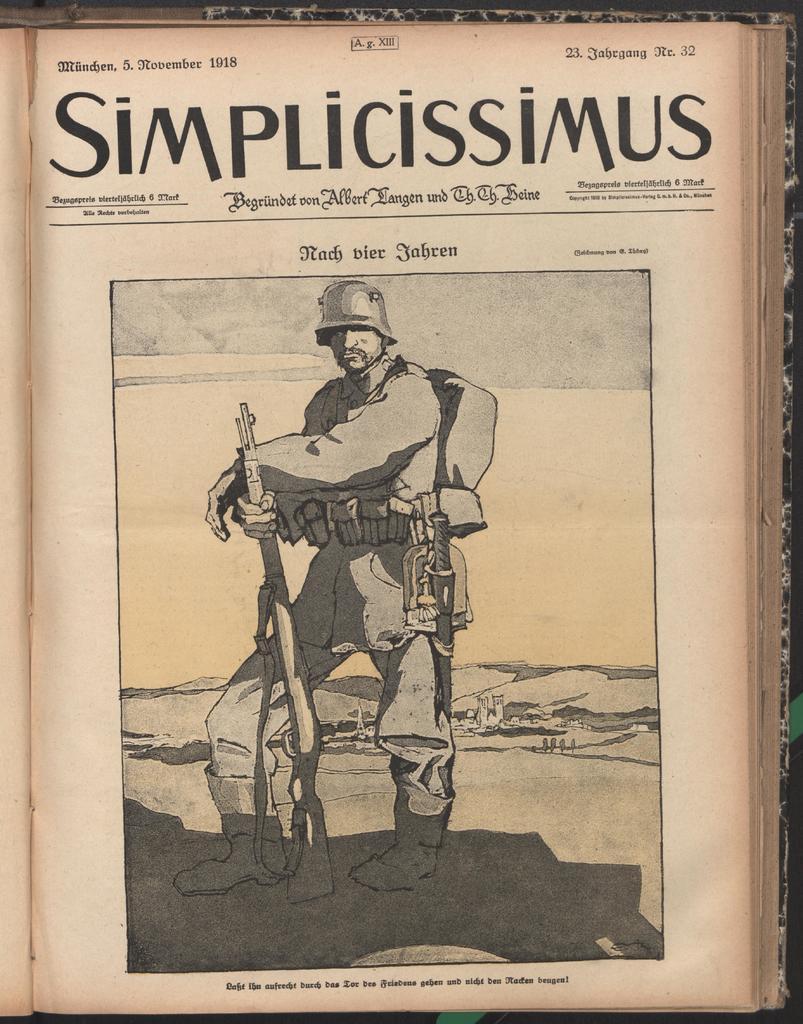In one or two sentences, can you explain what this image depicts? In this image we can see picture of a person and texts written on a paper of a book. 